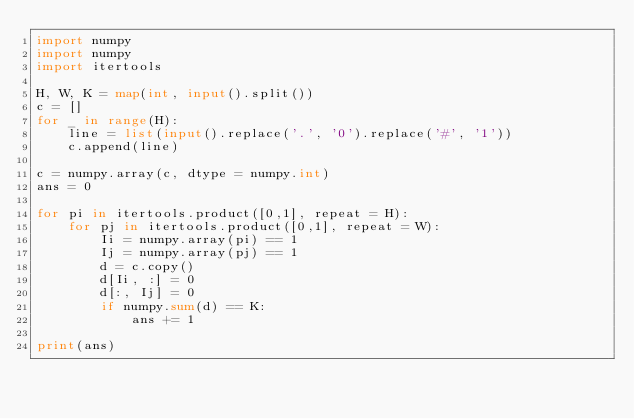<code> <loc_0><loc_0><loc_500><loc_500><_Python_>import numpy
import numpy
import itertools

H, W, K = map(int, input().split())
c = []
for _ in range(H):
    line = list(input().replace('.', '0').replace('#', '1'))
    c.append(line)

c = numpy.array(c, dtype = numpy.int)
ans = 0

for pi in itertools.product([0,1], repeat = H):
    for pj in itertools.product([0,1], repeat = W):
        Ii = numpy.array(pi) == 1
        Ij = numpy.array(pj) == 1
        d = c.copy()
        d[Ii, :] = 0
        d[:, Ij] = 0
        if numpy.sum(d) == K:
            ans += 1

print(ans)</code> 